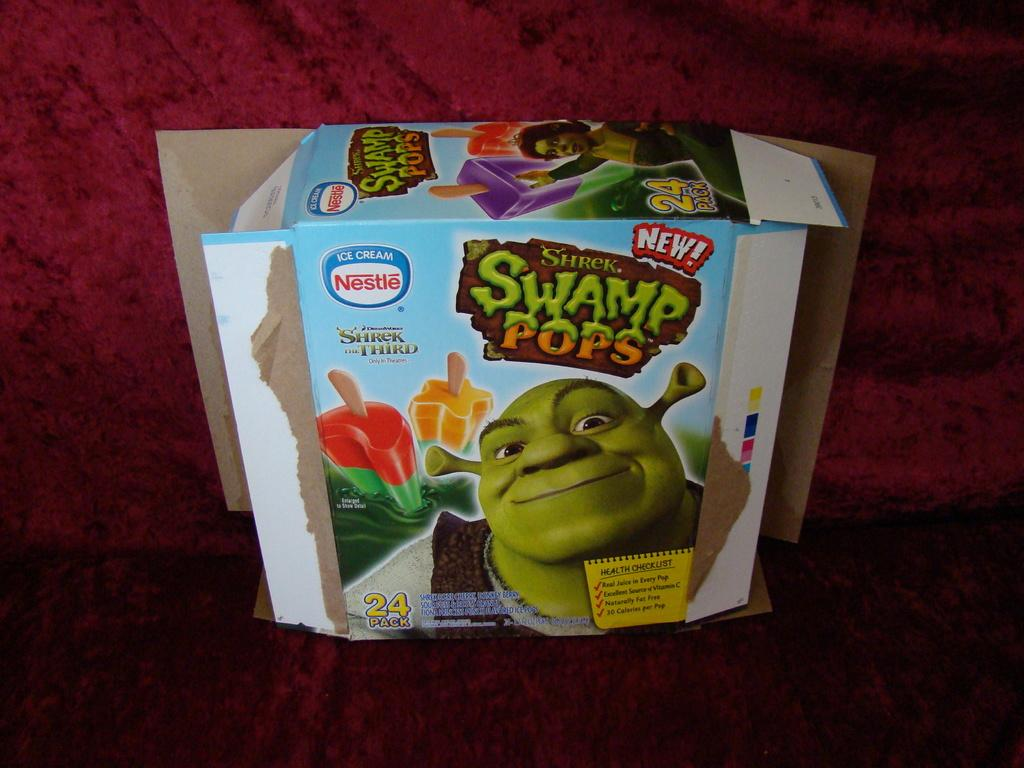What is the dominant color of the surface in the image? The surface in the image has a red color. What type of object is in the image that can be opened on two sides? There is a box in the image that opens on two sides. What is written on the box in the image? The words "swamp pop" are written on the box in the image. How many degrees does the box in the image have? The image does not provide information about the degrees of the box, as it is not relevant to the image's content. 